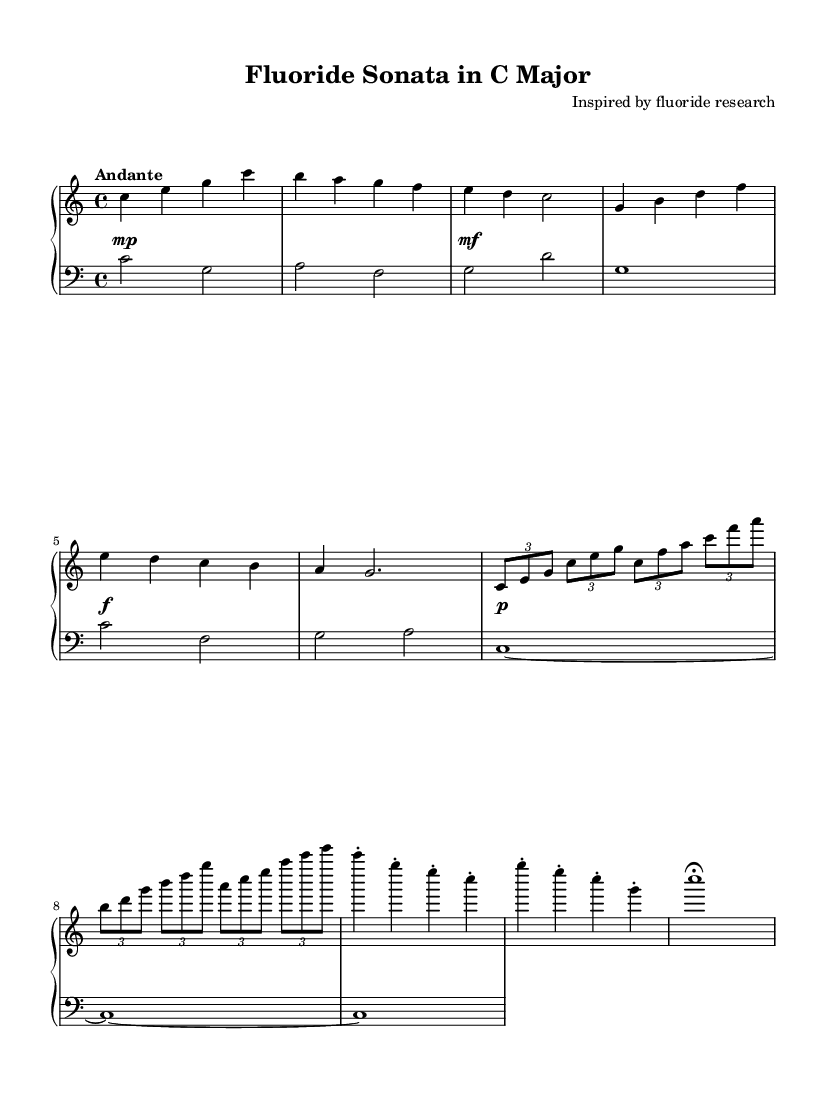What is the key signature of this music? The key signature is C major, which has no sharps or flats.
Answer: C major What is the time signature of this piece? The time signature is indicated at the beginning of the score as 4/4, which means there are four beats in each measure, and the quarter note gets one beat.
Answer: 4/4 What is the tempo marking for this sonata? The tempo marking is "Andante," which typically indicates a moderate speed of walking pace.
Answer: Andante How many measures are in the main theme? The main theme consists of 5 measures, starting from the first measure up to the measure before the secondary theme begins.
Answer: 5 What dynamic level is indicated at the start of the piece? The dynamic level at the start is marked as "mp," which stands for mezzo-piano, indicating a moderately soft volume.
Answer: mp What type of musical form is primarily used in this sonata? The music exhibits a sonata form, typically structured in exposition, development, and recapitulation sections, as seen in the thematic organization.
Answer: Sonata form How many times does the left hand play during the coda section? The left hand plays three times in the coda section, with specific notes indicated for each of the last three measures.
Answer: 3 